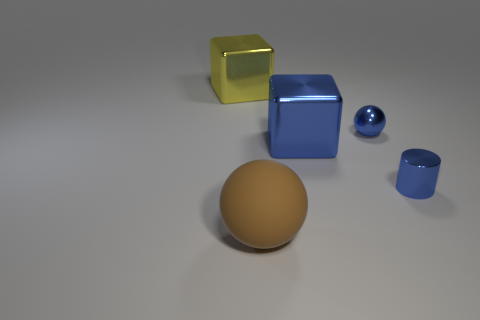What color is the tiny metal object that is the same shape as the brown rubber thing?
Your answer should be very brief. Blue. Do the blue cylinder and the yellow metallic block have the same size?
Provide a succinct answer. No. Are there an equal number of blue metal balls that are behind the small blue metal sphere and purple matte cylinders?
Offer a very short reply. Yes. There is a large object that is behind the large blue metallic block; is there a yellow metallic object behind it?
Offer a terse response. No. What is the size of the ball behind the small object that is in front of the blue object that is behind the big blue object?
Your response must be concise. Small. There is a ball behind the brown rubber thing that is to the left of the blue cube; what is it made of?
Offer a very short reply. Metal. Is there a blue metallic thing that has the same shape as the yellow metallic object?
Keep it short and to the point. Yes. There is a large yellow shiny object; what shape is it?
Ensure brevity in your answer.  Cube. What material is the thing that is behind the small blue object that is on the left side of the tiny blue metallic thing in front of the large blue cube?
Keep it short and to the point. Metal. Are there more cylinders that are left of the tiny blue metal sphere than big yellow things?
Give a very brief answer. No. 